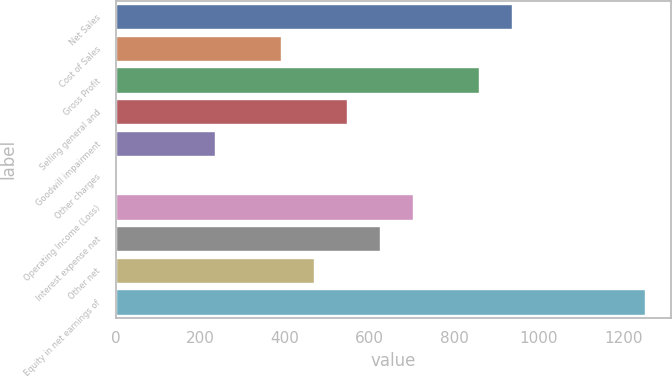Convert chart to OTSL. <chart><loc_0><loc_0><loc_500><loc_500><bar_chart><fcel>Net Sales<fcel>Cost of Sales<fcel>Gross Profit<fcel>Selling general and<fcel>Goodwill impairment<fcel>Other charges<fcel>Operating Income (Loss)<fcel>Interest expense net<fcel>Other net<fcel>Equity in net earnings of<nl><fcel>938.23<fcel>391.32<fcel>860.1<fcel>547.58<fcel>235.06<fcel>0.67<fcel>703.84<fcel>625.71<fcel>469.45<fcel>1250.75<nl></chart> 